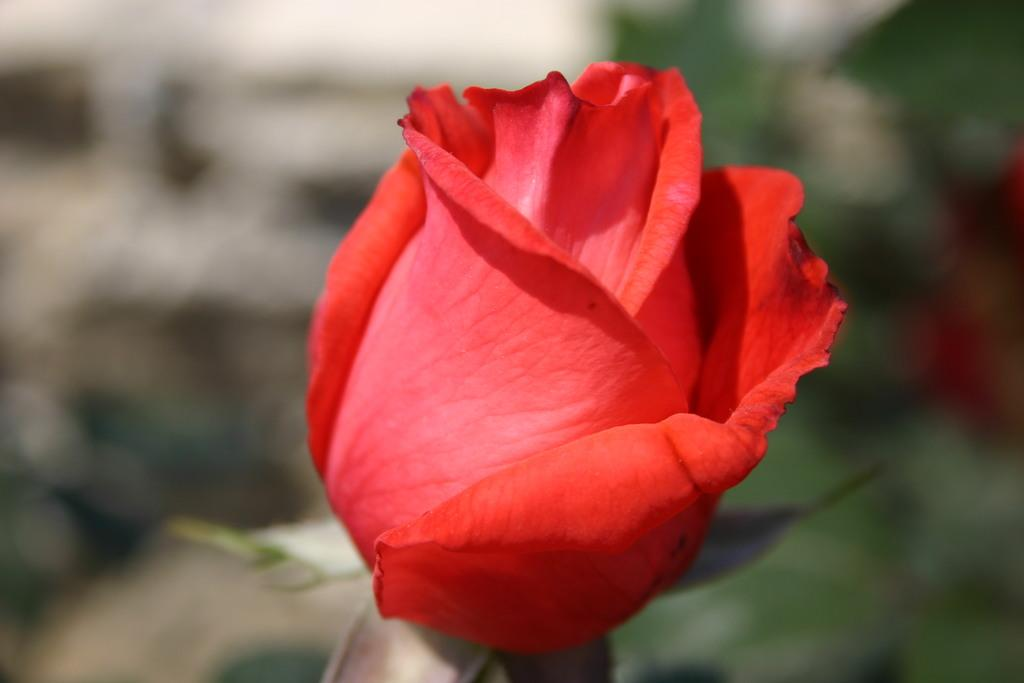What type of flower is in the picture? There is a red rose in the picture. Can you describe the background of the picture? The background of the picture is blurred. How many servants are attending to the red rose in the picture? There are no servants present in the image; it only features a red rose and a blurred background. 